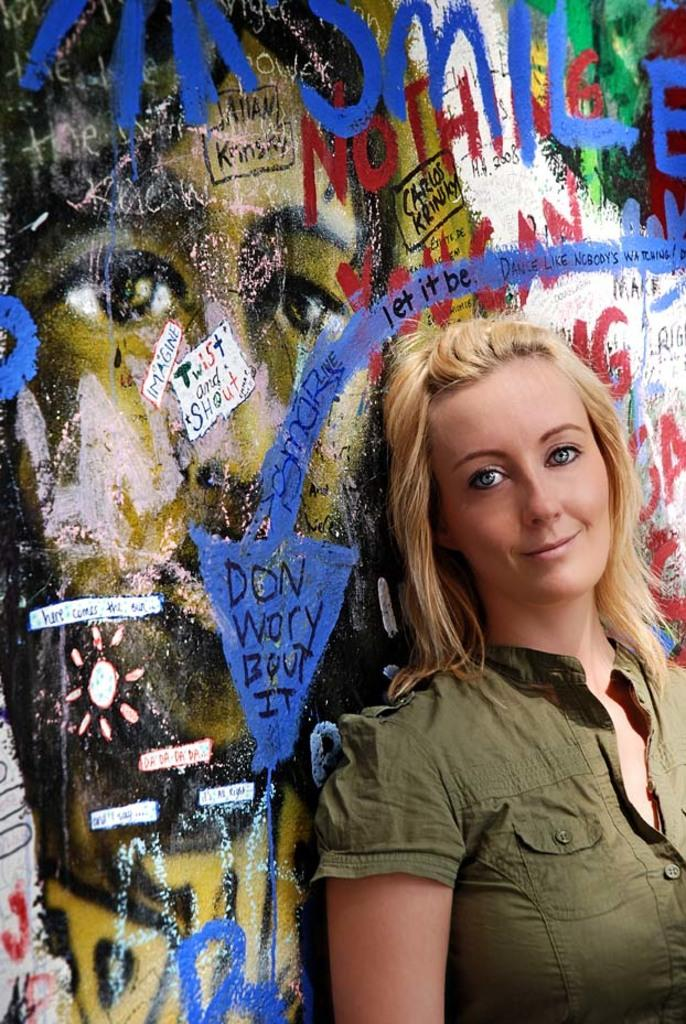Who is present in the image? There is a woman in the image. What is the woman's facial expression? The woman is smiling. What can be seen in the background of the image? There is a painting and something written on the wall in the background of the image. What type of clover is growing on the woman's shoulder in the image? There is no clover present in the image, and nothing is growing on the woman's shoulder. 